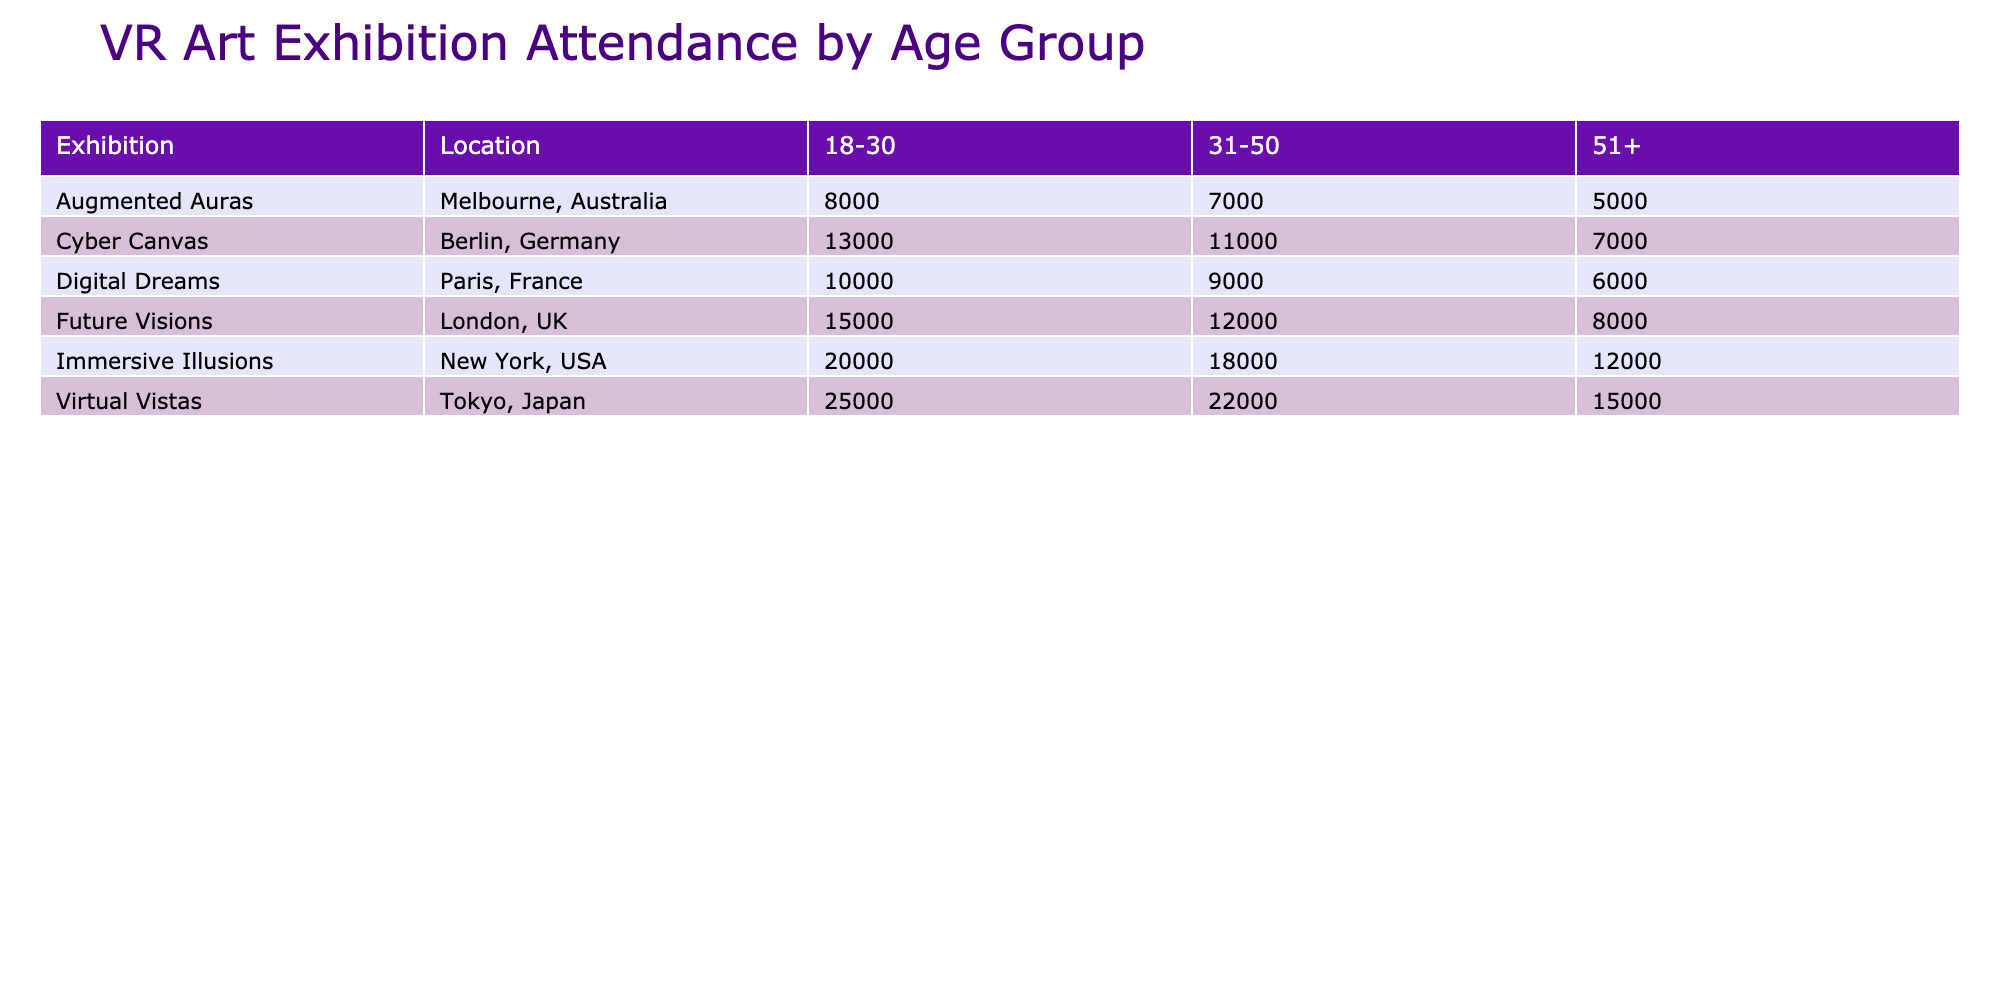what is the total number of visitors for the exhibition "Future Visions"? The total number of visitors for "Future Visions" can be found by looking at the row in the table that corresponds to the exhibition name. The total is 15000 + 12000 + 8000 = 35000.
Answer: 35000 which age group had the highest average satisfaction rating at the "Immersive Illusions" exhibition? To find the highest average satisfaction rating for "Immersive Illusions," we compare the ratings given for each age group, which are 4.8 for 18-30, 4.6 for 31-50, and 4.3 for 51+. The highest rating is 4.8 for the age group 18-30.
Answer: 18-30 how many total visitors attended VR exhibitions in Paris in 2021? We sum the total visitors for all VR exhibitions in Paris in 2021, which are: "Digital Dreams" 10000 + 9000 + 6000 = 25000.
Answer: 25000 is the average time spent by visitors in the "Cyber Canvas" exhibition greater than 40 minutes? The average time spent at "Cyber Canvas" is 40 minutes for the 18-30 age group, 35 minutes for 31-50, and 30 minutes for 51+. The only average that meets the condition is 40 minutes, so it is not greater than 40.
Answer: No what percentage of total visitors in "Virtual Vistas" were from the age group "51+"? The total visitors for "Virtual Vistas" are 25000 + 22000 + 15000 = 62000. The visitors from the "51+" age group are 15000. To find the percentage, divide 15000 by 62000 and multiply by 100, which gives (15000 / 62000) * 100 = 24.19%.
Answer: 24.19% 